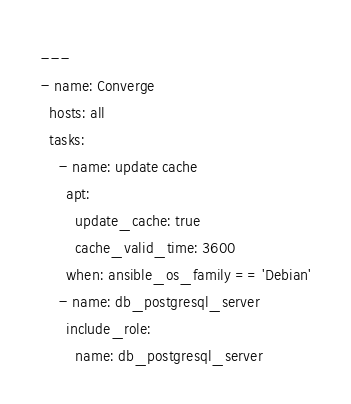<code> <loc_0><loc_0><loc_500><loc_500><_YAML_>---
- name: Converge
  hosts: all
  tasks:
    - name: update cache
      apt:
        update_cache: true
        cache_valid_time: 3600
      when: ansible_os_family == 'Debian'
    - name: db_postgresql_server
      include_role:
        name: db_postgresql_server
</code> 